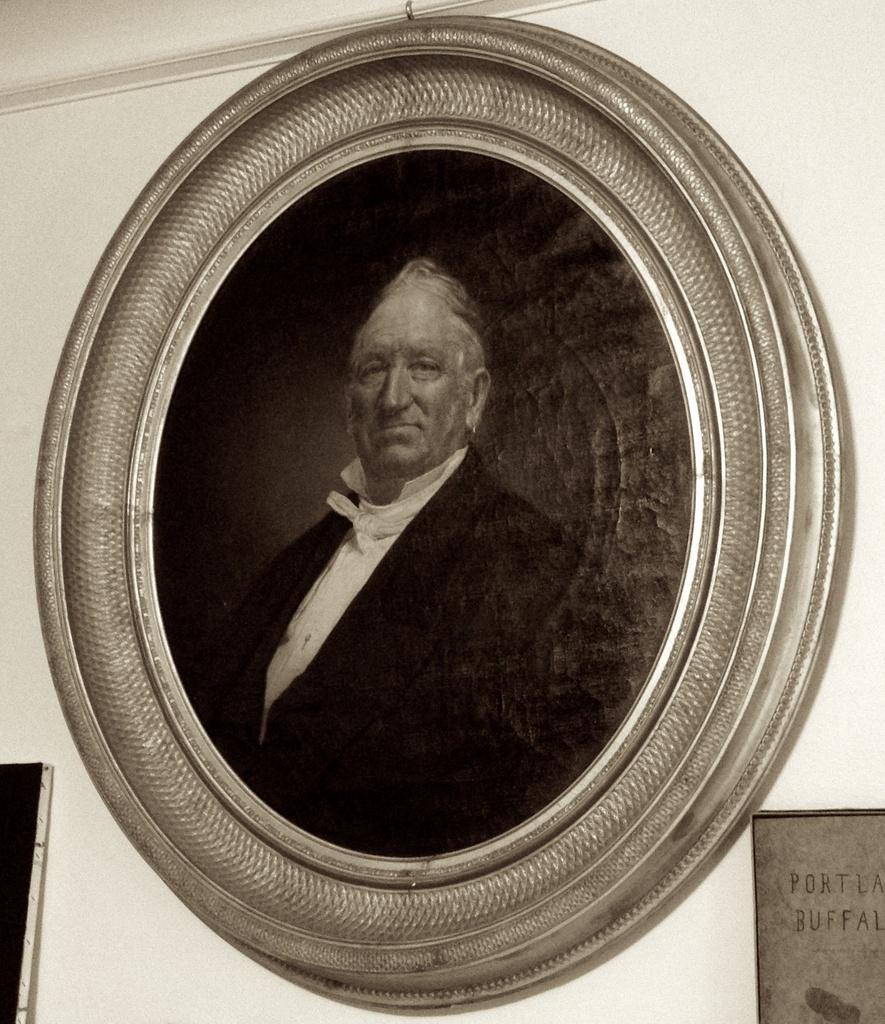What type of structure can be seen in the image? There is a wall in the image. What is hanging on the wall in the image? There is a photo frame in the image. What is depicted in the photo frame? The photo frame contains a picture of a man. What is the man wearing in the picture? The man is wearing a black jacket in the picture. What company does the man in the picture work for? The image does not provide any information about the man's company or occupation. Does the man in the picture feel any shame? There is no indication of the man's emotions or feelings in the image. 